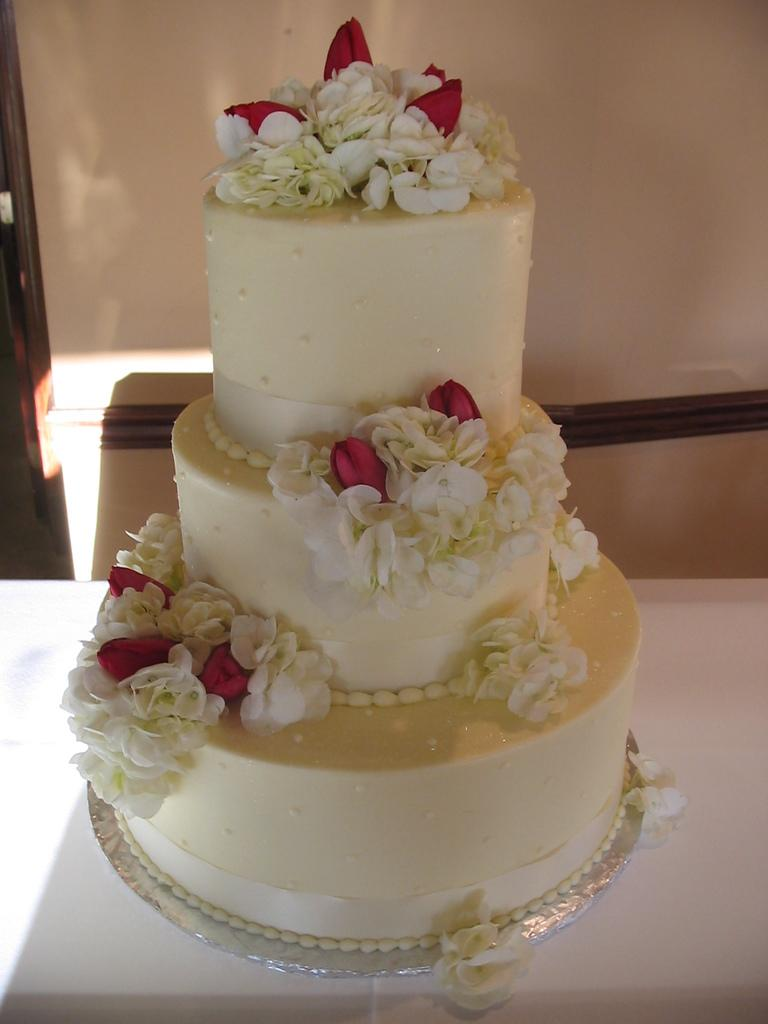What type of cake is shown in the image? There is a step cake in the image. Are there any decorations on the step cake? Yes, the step cake has flowers on it. What type of wing is visible on the step cake in the image? There are no wings visible on the step cake in the image. 